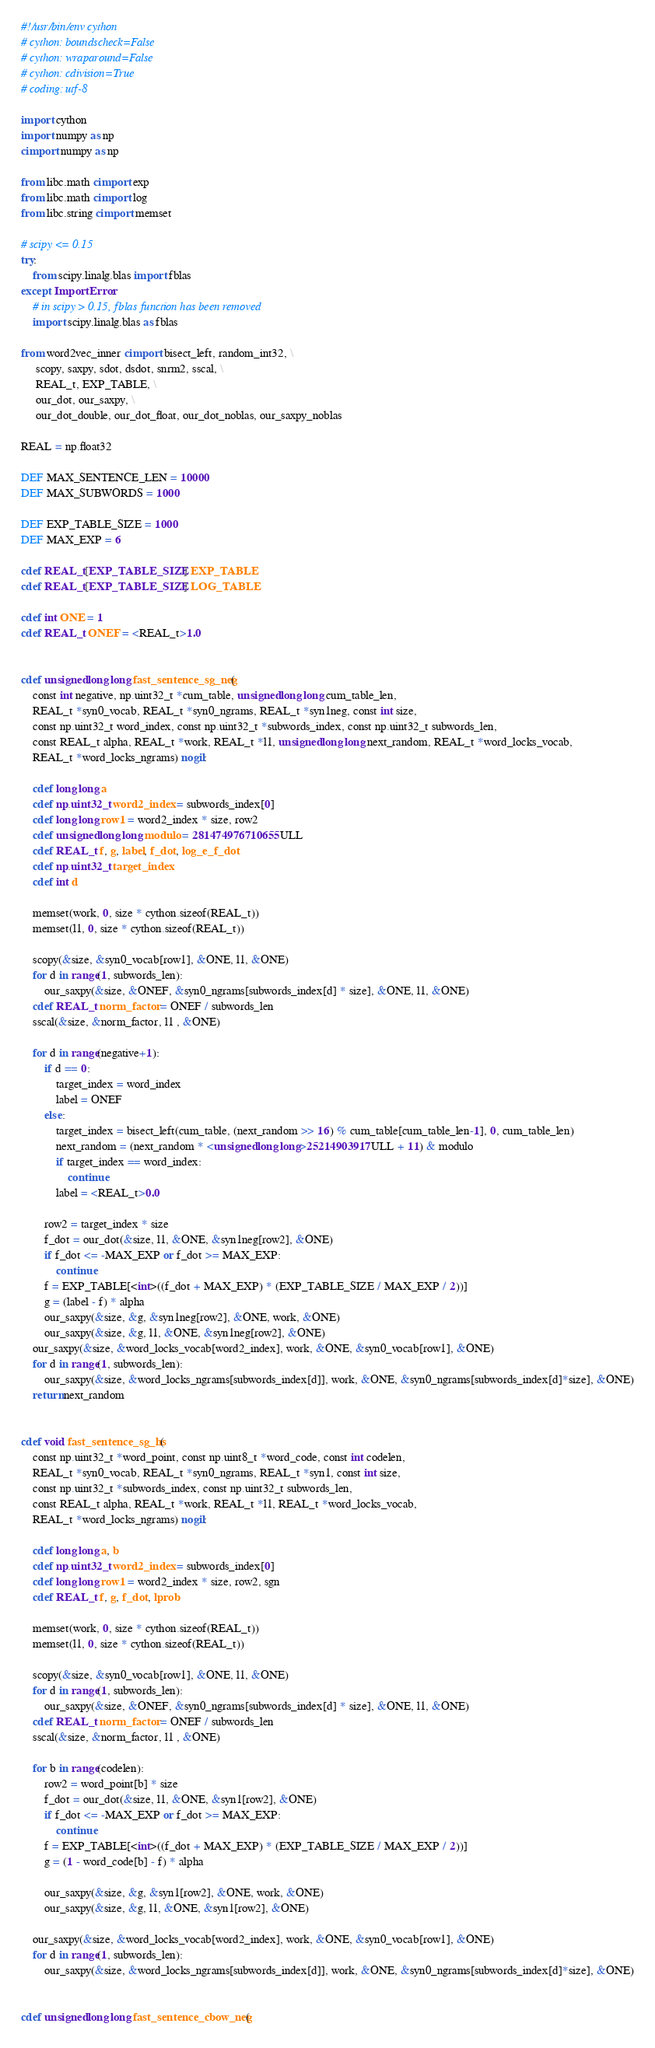Convert code to text. <code><loc_0><loc_0><loc_500><loc_500><_Cython_>#!/usr/bin/env cython
# cython: boundscheck=False
# cython: wraparound=False
# cython: cdivision=True
# coding: utf-8

import cython
import numpy as np
cimport numpy as np

from libc.math cimport exp
from libc.math cimport log
from libc.string cimport memset

# scipy <= 0.15
try:
    from scipy.linalg.blas import fblas
except ImportError:
    # in scipy > 0.15, fblas function has been removed
    import scipy.linalg.blas as fblas

from word2vec_inner cimport bisect_left, random_int32, \
     scopy, saxpy, sdot, dsdot, snrm2, sscal, \
     REAL_t, EXP_TABLE, \
     our_dot, our_saxpy, \
     our_dot_double, our_dot_float, our_dot_noblas, our_saxpy_noblas

REAL = np.float32

DEF MAX_SENTENCE_LEN = 10000
DEF MAX_SUBWORDS = 1000

DEF EXP_TABLE_SIZE = 1000
DEF MAX_EXP = 6

cdef REAL_t[EXP_TABLE_SIZE] EXP_TABLE
cdef REAL_t[EXP_TABLE_SIZE] LOG_TABLE

cdef int ONE = 1
cdef REAL_t ONEF = <REAL_t>1.0


cdef unsigned long long fast_sentence_sg_neg(
    const int negative, np.uint32_t *cum_table, unsigned long long cum_table_len,
    REAL_t *syn0_vocab, REAL_t *syn0_ngrams, REAL_t *syn1neg, const int size,
    const np.uint32_t word_index, const np.uint32_t *subwords_index, const np.uint32_t subwords_len,
    const REAL_t alpha, REAL_t *work, REAL_t *l1, unsigned long long next_random, REAL_t *word_locks_vocab,
    REAL_t *word_locks_ngrams) nogil:

    cdef long long a
    cdef np.uint32_t word2_index = subwords_index[0]
    cdef long long row1 = word2_index * size, row2
    cdef unsigned long long modulo = 281474976710655ULL
    cdef REAL_t f, g, label, f_dot, log_e_f_dot
    cdef np.uint32_t target_index
    cdef int d

    memset(work, 0, size * cython.sizeof(REAL_t))
    memset(l1, 0, size * cython.sizeof(REAL_t))

    scopy(&size, &syn0_vocab[row1], &ONE, l1, &ONE)
    for d in range(1, subwords_len):
        our_saxpy(&size, &ONEF, &syn0_ngrams[subwords_index[d] * size], &ONE, l1, &ONE)
    cdef REAL_t norm_factor = ONEF / subwords_len
    sscal(&size, &norm_factor, l1 , &ONE)

    for d in range(negative+1):
        if d == 0:
            target_index = word_index
            label = ONEF
        else:
            target_index = bisect_left(cum_table, (next_random >> 16) % cum_table[cum_table_len-1], 0, cum_table_len)
            next_random = (next_random * <unsigned long long>25214903917ULL + 11) & modulo
            if target_index == word_index:
                continue
            label = <REAL_t>0.0

        row2 = target_index * size
        f_dot = our_dot(&size, l1, &ONE, &syn1neg[row2], &ONE)
        if f_dot <= -MAX_EXP or f_dot >= MAX_EXP:
            continue
        f = EXP_TABLE[<int>((f_dot + MAX_EXP) * (EXP_TABLE_SIZE / MAX_EXP / 2))]
        g = (label - f) * alpha
        our_saxpy(&size, &g, &syn1neg[row2], &ONE, work, &ONE)
        our_saxpy(&size, &g, l1, &ONE, &syn1neg[row2], &ONE)
    our_saxpy(&size, &word_locks_vocab[word2_index], work, &ONE, &syn0_vocab[row1], &ONE)
    for d in range(1, subwords_len):
        our_saxpy(&size, &word_locks_ngrams[subwords_index[d]], work, &ONE, &syn0_ngrams[subwords_index[d]*size], &ONE)
    return next_random


cdef void fast_sentence_sg_hs(
    const np.uint32_t *word_point, const np.uint8_t *word_code, const int codelen,
    REAL_t *syn0_vocab, REAL_t *syn0_ngrams, REAL_t *syn1, const int size,
    const np.uint32_t *subwords_index, const np.uint32_t subwords_len, 
    const REAL_t alpha, REAL_t *work, REAL_t *l1, REAL_t *word_locks_vocab,
    REAL_t *word_locks_ngrams) nogil:

    cdef long long a, b
    cdef np.uint32_t word2_index = subwords_index[0]
    cdef long long row1 = word2_index * size, row2, sgn
    cdef REAL_t f, g, f_dot, lprob

    memset(work, 0, size * cython.sizeof(REAL_t))
    memset(l1, 0, size * cython.sizeof(REAL_t))

    scopy(&size, &syn0_vocab[row1], &ONE, l1, &ONE)
    for d in range(1, subwords_len):
        our_saxpy(&size, &ONEF, &syn0_ngrams[subwords_index[d] * size], &ONE, l1, &ONE)
    cdef REAL_t norm_factor = ONEF / subwords_len
    sscal(&size, &norm_factor, l1 , &ONE)

    for b in range(codelen):
        row2 = word_point[b] * size
        f_dot = our_dot(&size, l1, &ONE, &syn1[row2], &ONE)
        if f_dot <= -MAX_EXP or f_dot >= MAX_EXP:
            continue
        f = EXP_TABLE[<int>((f_dot + MAX_EXP) * (EXP_TABLE_SIZE / MAX_EXP / 2))]
        g = (1 - word_code[b] - f) * alpha

        our_saxpy(&size, &g, &syn1[row2], &ONE, work, &ONE)
        our_saxpy(&size, &g, l1, &ONE, &syn1[row2], &ONE)

    our_saxpy(&size, &word_locks_vocab[word2_index], work, &ONE, &syn0_vocab[row1], &ONE)
    for d in range(1, subwords_len):
        our_saxpy(&size, &word_locks_ngrams[subwords_index[d]], work, &ONE, &syn0_ngrams[subwords_index[d]*size], &ONE)


cdef unsigned long long fast_sentence_cbow_neg(</code> 